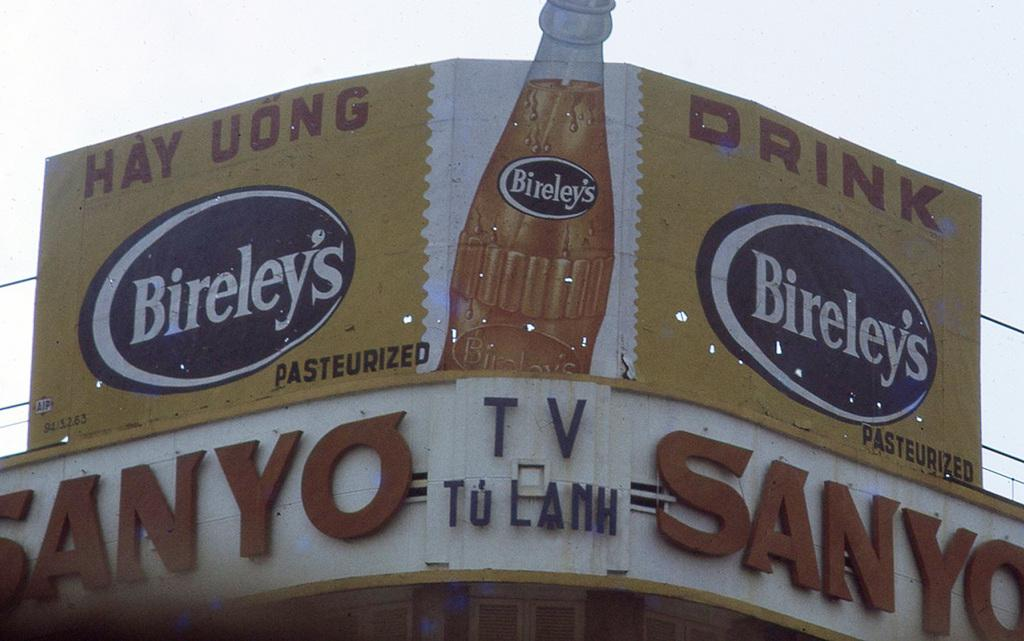<image>
Create a compact narrative representing the image presented. A sign above a Sanyo TV store that says "Drink Bireley's Pasteurized" 